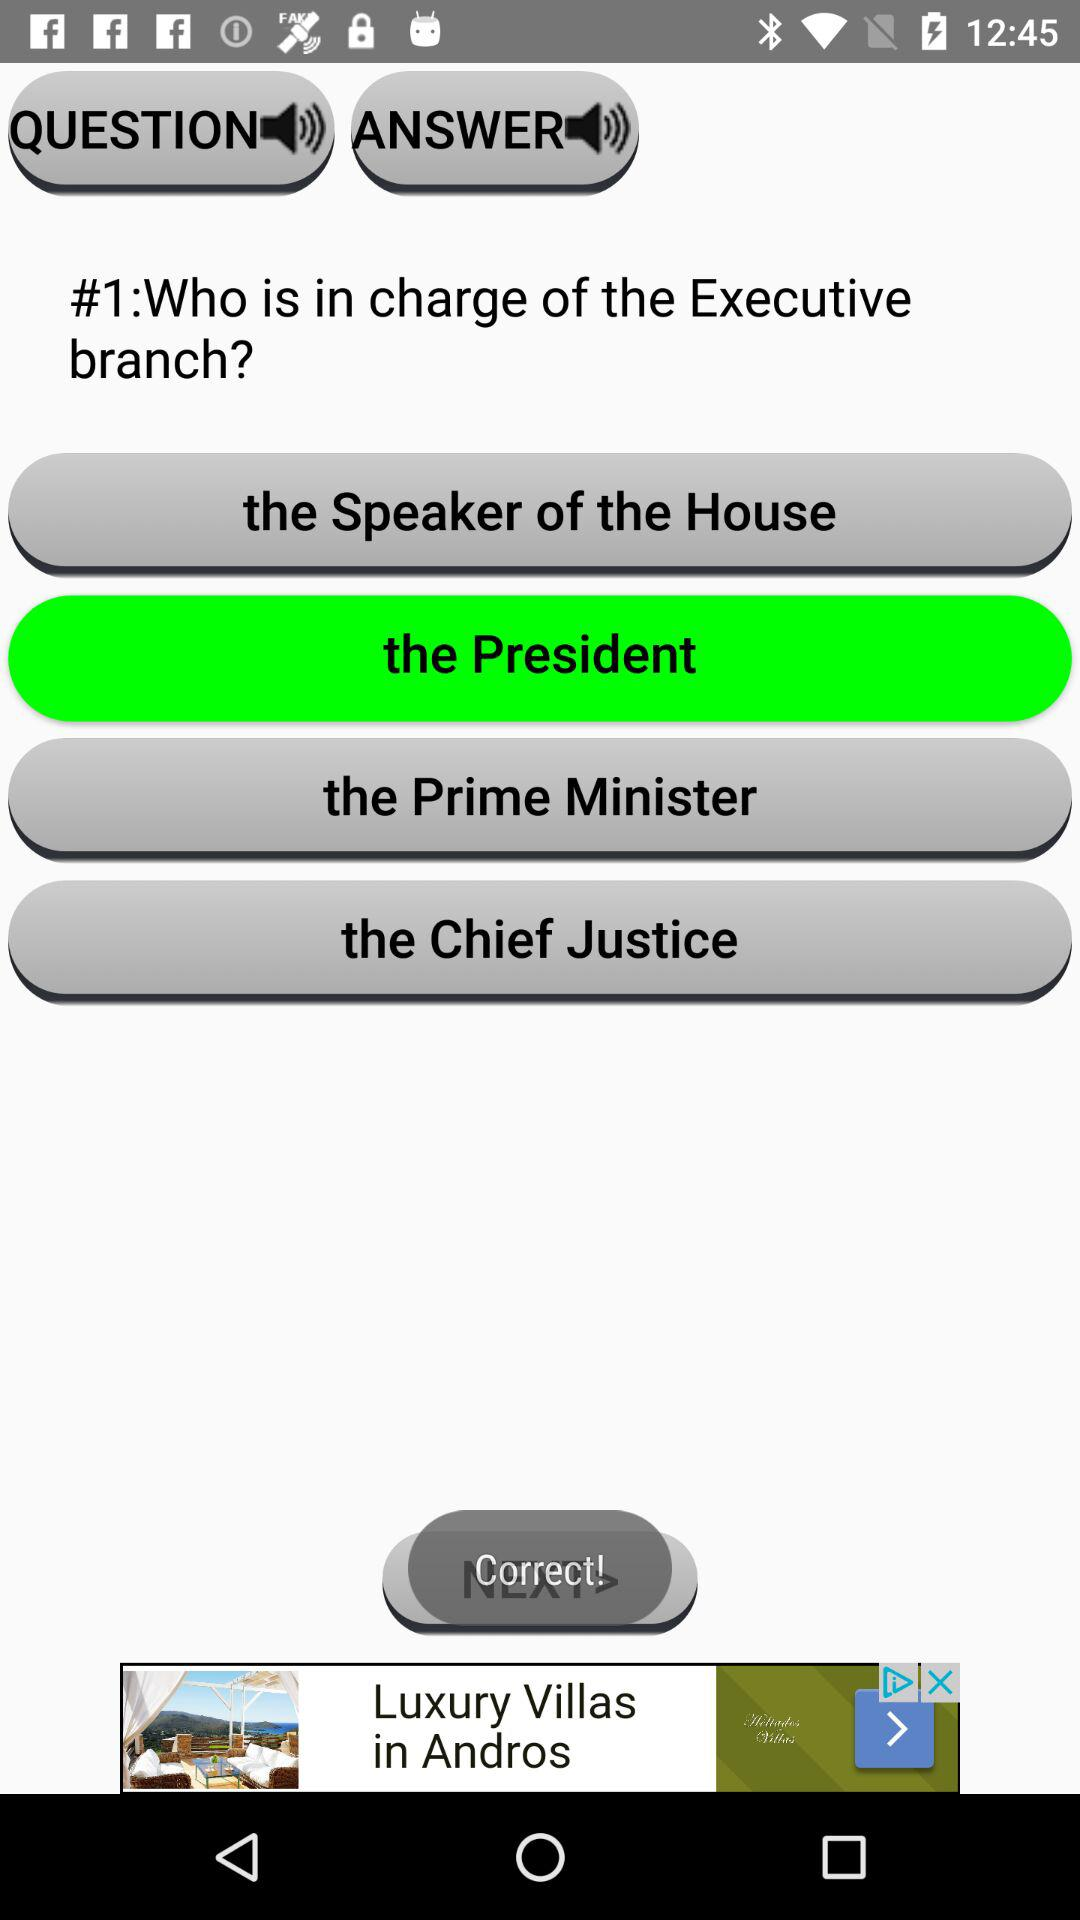What's the selected answer to the question? The selected answer to the question is "the President". 